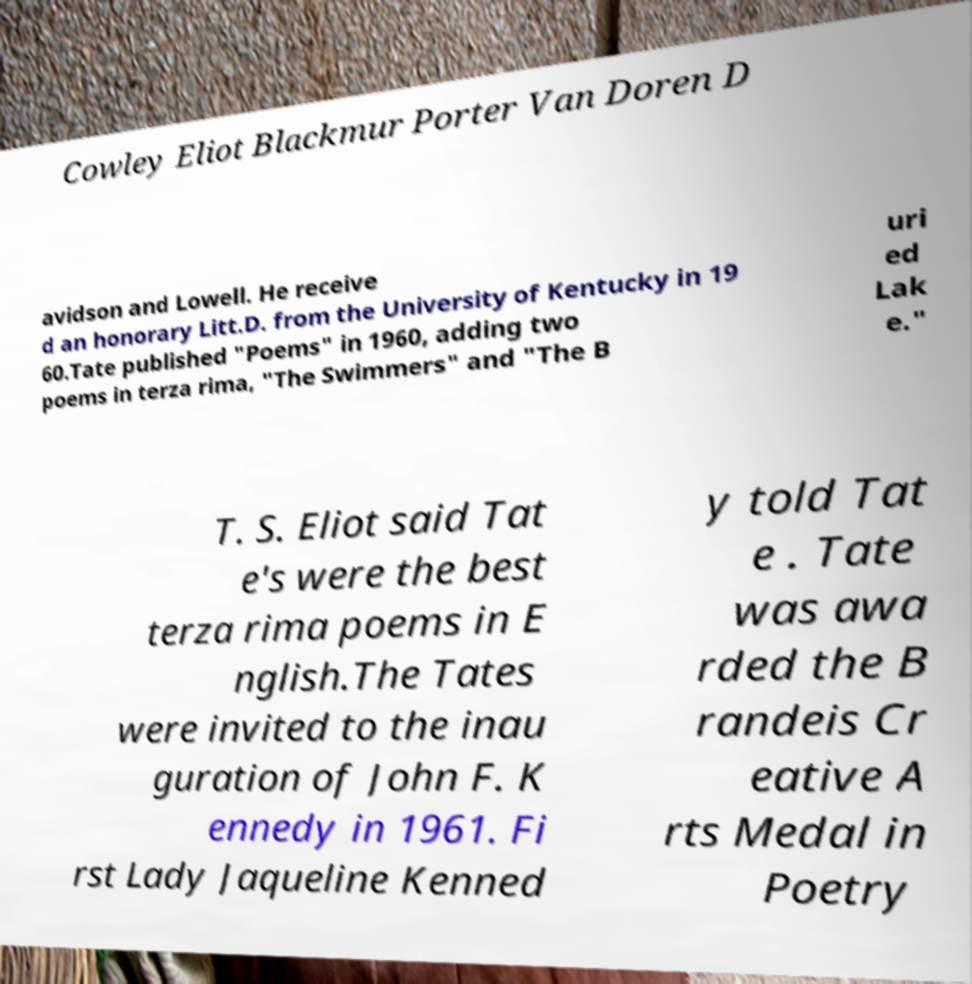What messages or text are displayed in this image? I need them in a readable, typed format. Cowley Eliot Blackmur Porter Van Doren D avidson and Lowell. He receive d an honorary Litt.D. from the University of Kentucky in 19 60.Tate published "Poems" in 1960, adding two poems in terza rima, "The Swimmers" and "The B uri ed Lak e." T. S. Eliot said Tat e's were the best terza rima poems in E nglish.The Tates were invited to the inau guration of John F. K ennedy in 1961. Fi rst Lady Jaqueline Kenned y told Tat e . Tate was awa rded the B randeis Cr eative A rts Medal in Poetry 